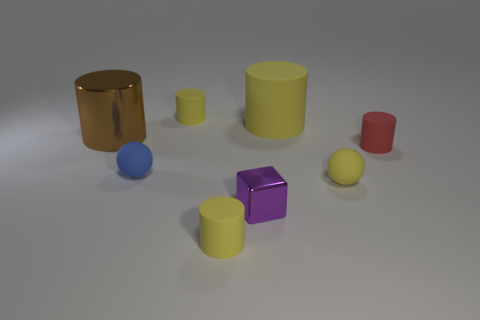What is the brown thing made of?
Make the answer very short. Metal. The small shiny object is what color?
Ensure brevity in your answer.  Purple. There is a tiny cylinder that is to the left of the red matte thing and in front of the brown metallic cylinder; what is its color?
Offer a very short reply. Yellow. Are there any other things that have the same material as the small purple cube?
Offer a terse response. Yes. Are the blue ball and the object that is left of the tiny blue ball made of the same material?
Provide a short and direct response. No. There is a blue matte sphere in front of the small rubber thing behind the small red cylinder; how big is it?
Provide a short and direct response. Small. Is there anything else of the same color as the metal cylinder?
Provide a short and direct response. No. Does the thing that is to the right of the yellow sphere have the same material as the yellow cylinder that is in front of the small blue rubber sphere?
Offer a terse response. Yes. There is a object that is to the left of the shiny cube and in front of the yellow matte ball; what is its material?
Give a very brief answer. Rubber. There is a brown object; is its shape the same as the tiny yellow thing that is behind the red object?
Your answer should be compact. Yes. 